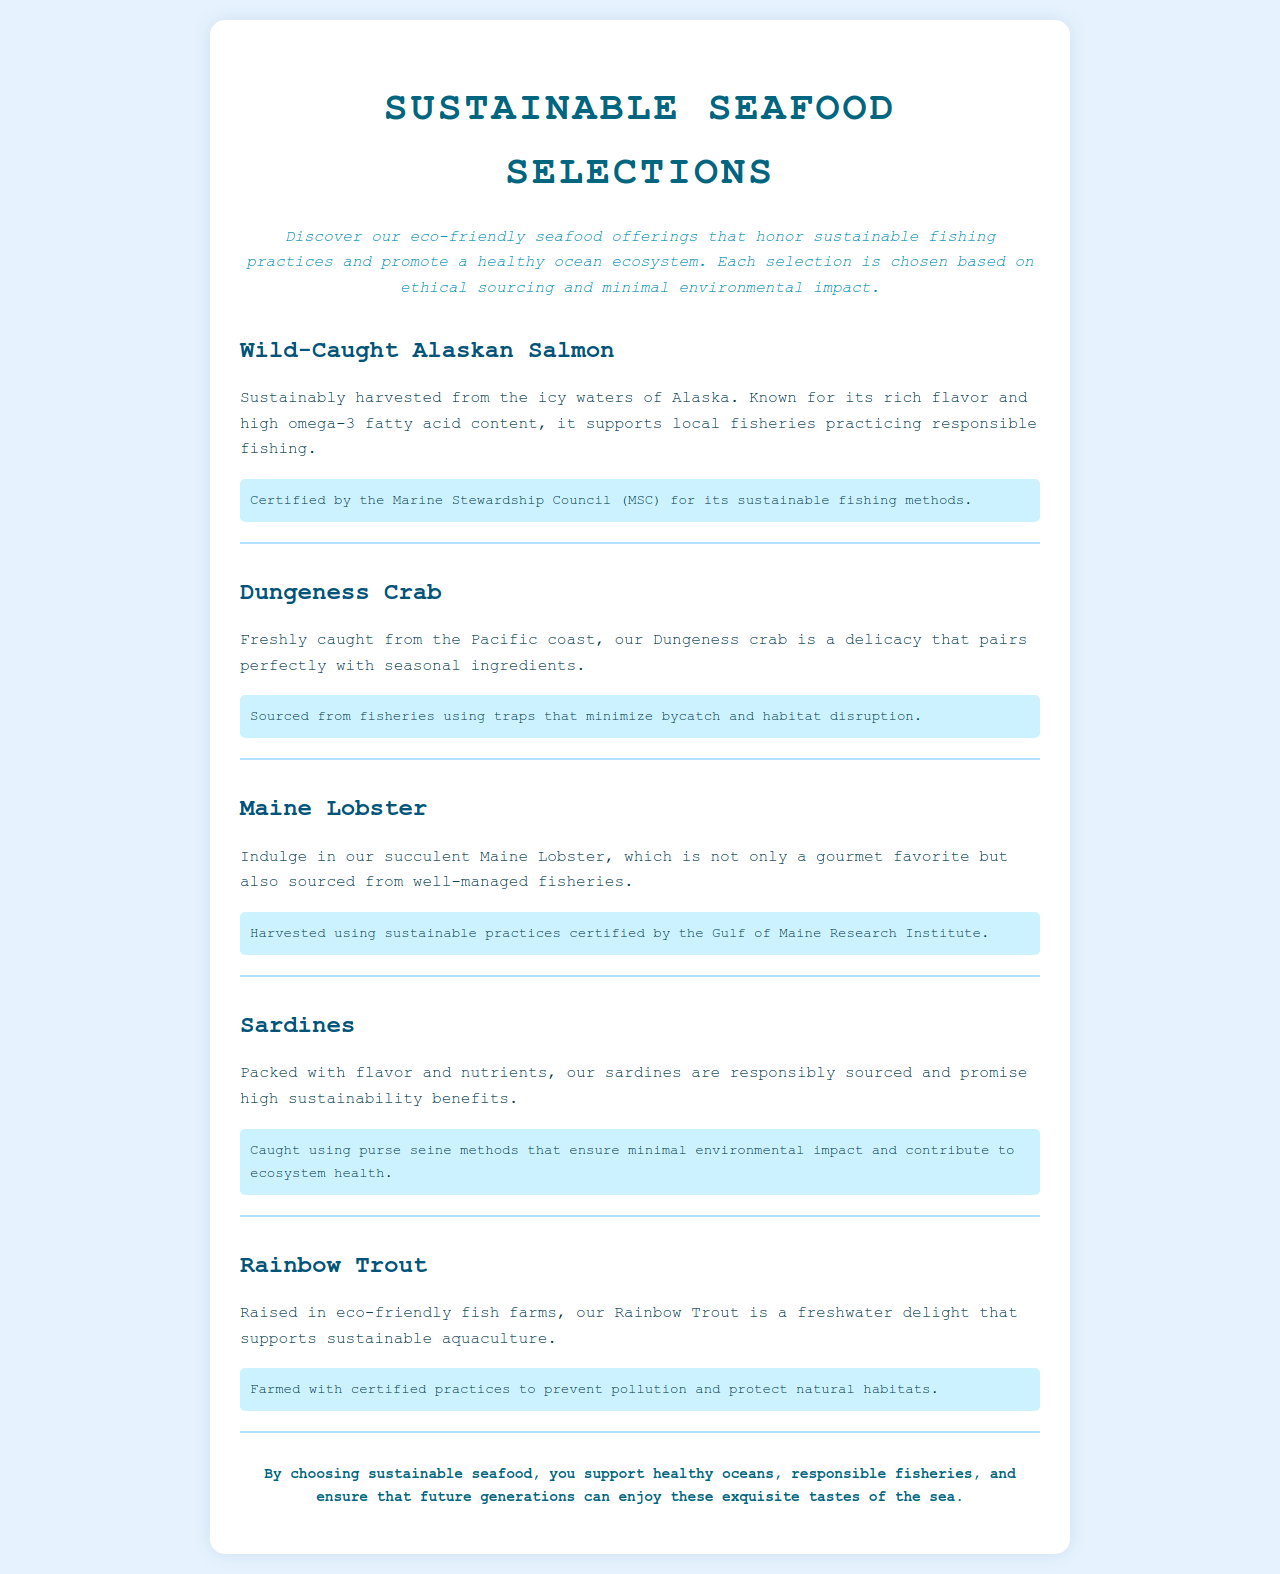What is the title of the document? The title is found in the `<title>` tag of the HTML document.
Answer: Sustainable Seafood Selections What certifications are mentioned for Wild-Caught Alaskan Salmon? The certification is mentioned in the description of the menu item.
Answer: Marine Stewardship Council (MSC) What type of crab is offered on the menu? The type of crab is specified in the name of the menu item.
Answer: Dungeness Crab How is Rainbow Trout sourced? The sourcing method is described in the paragraph for Rainbow Trout.
Answer: Eco-friendly fish farms What does the description say about sardines? The description provides insights into the characteristics of sardines.
Answer: Packed with flavor and nutrients What sustainable practice is employed for Maine Lobster? The sustainable practice is included in the eco-practice note for the menu item.
Answer: Certified by the Gulf of Maine Research Institute Why is Dungeness Crab considered ecologically responsible? The ecological responsibility is detailed in the description of its fishing method.
Answer: Minimize bycatch and habitat disruption What kind of fishing method is used for sardines? The fishing method is explained in the eco-practice note for sardines.
Answer: Purse seine methods What is emphasized about choosing sustainable seafood? This emphasis is found in the footer of the document.
Answer: Support healthy oceans 